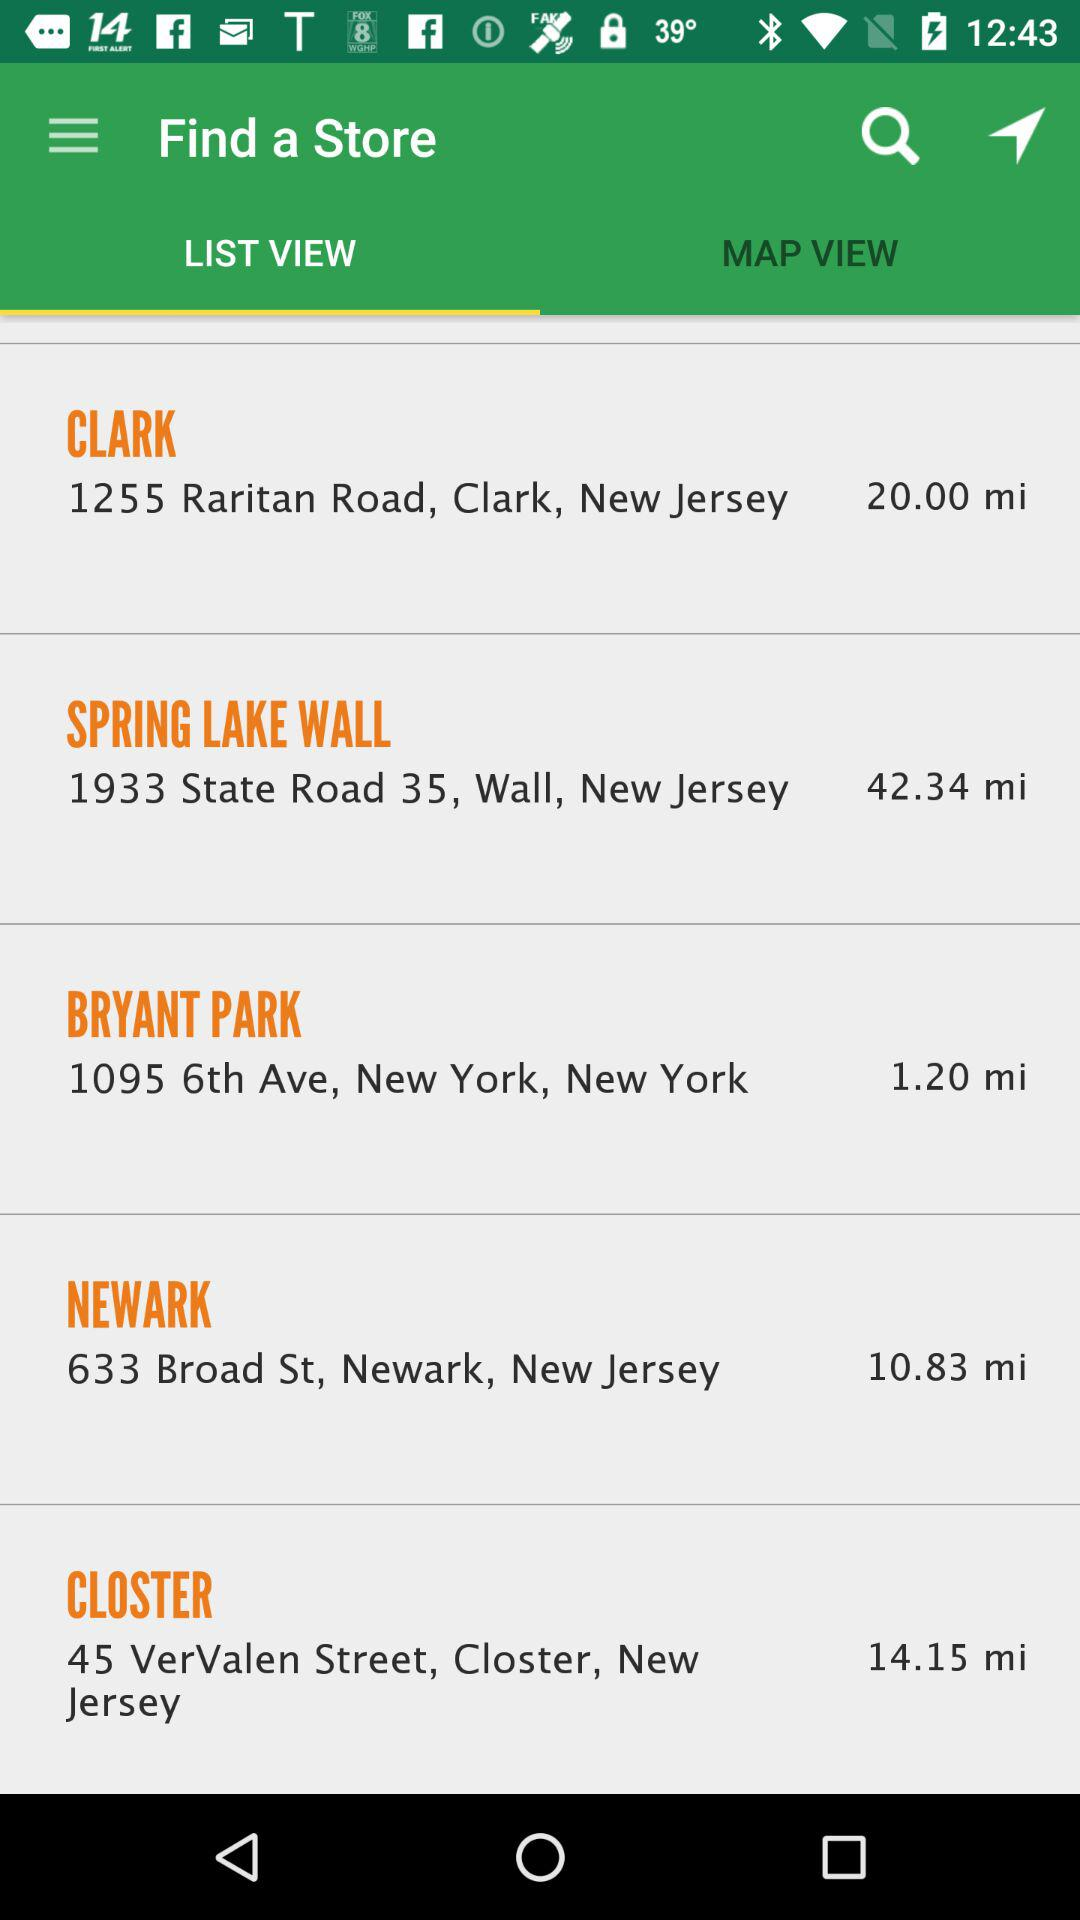What is the address of Bryant Park? The address is 1095 6th Avenue, New York, New York. 